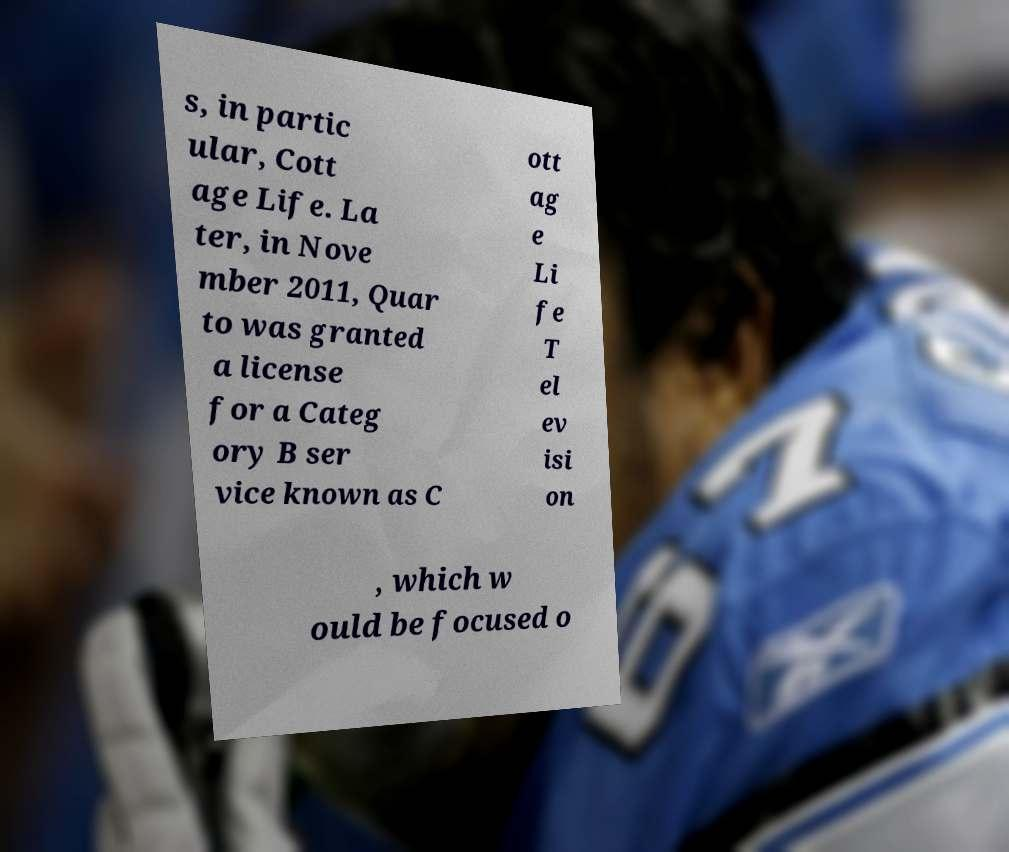Please read and relay the text visible in this image. What does it say? s, in partic ular, Cott age Life. La ter, in Nove mber 2011, Quar to was granted a license for a Categ ory B ser vice known as C ott ag e Li fe T el ev isi on , which w ould be focused o 